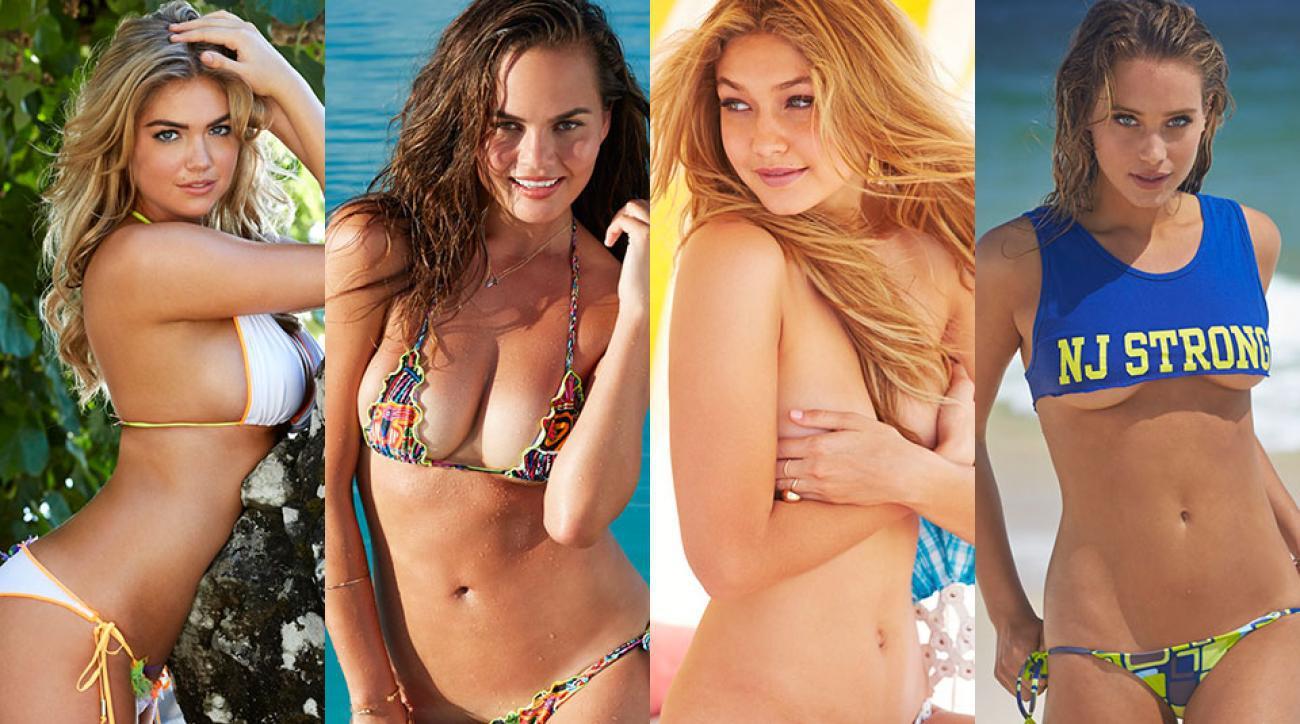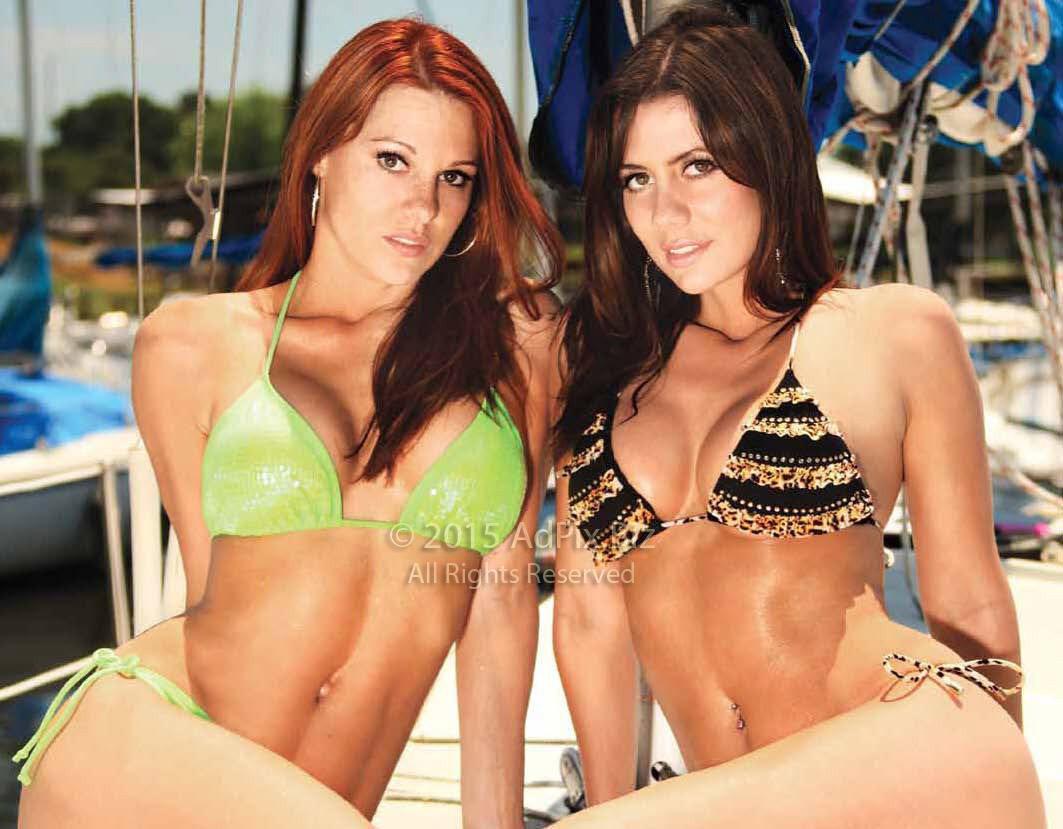The first image is the image on the left, the second image is the image on the right. Evaluate the accuracy of this statement regarding the images: "At least one of the women in the image on the right is wearing sunglasses.". Is it true? Answer yes or no. No. 